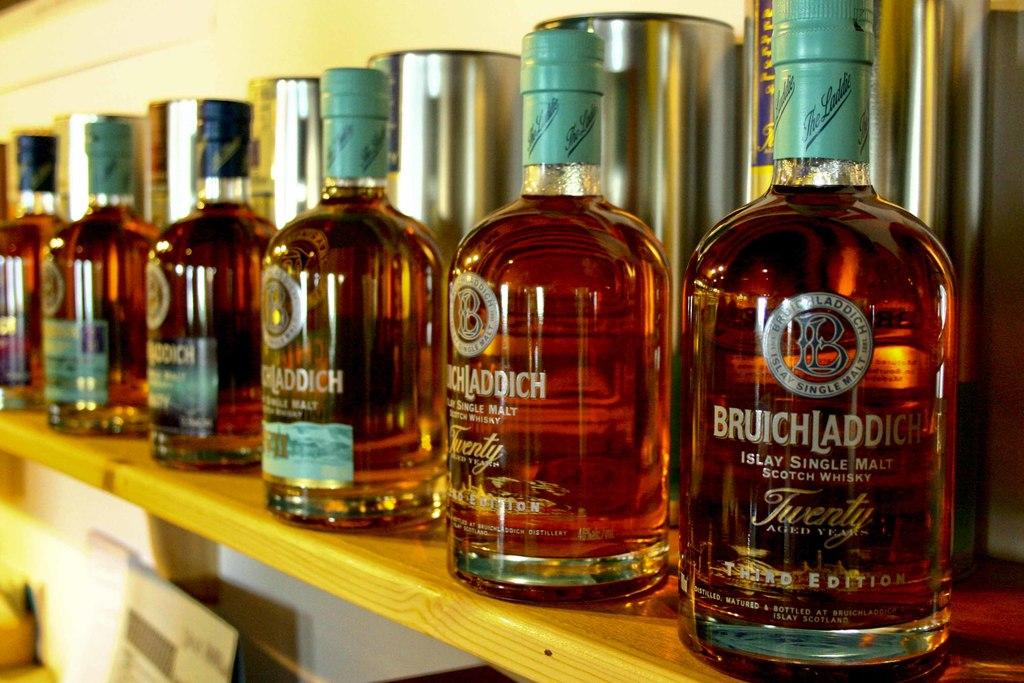<image>
Create a compact narrative representing the image presented. Multiple bottles of Bruichladdich whisky sit lined up on a wooden shelf. 